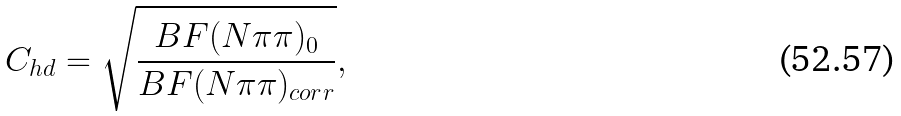<formula> <loc_0><loc_0><loc_500><loc_500>C _ { h d } = \sqrt { \frac { B F ( N \pi \pi ) _ { 0 } } { B F ( N \pi \pi ) _ { c o r r } } } ,</formula> 